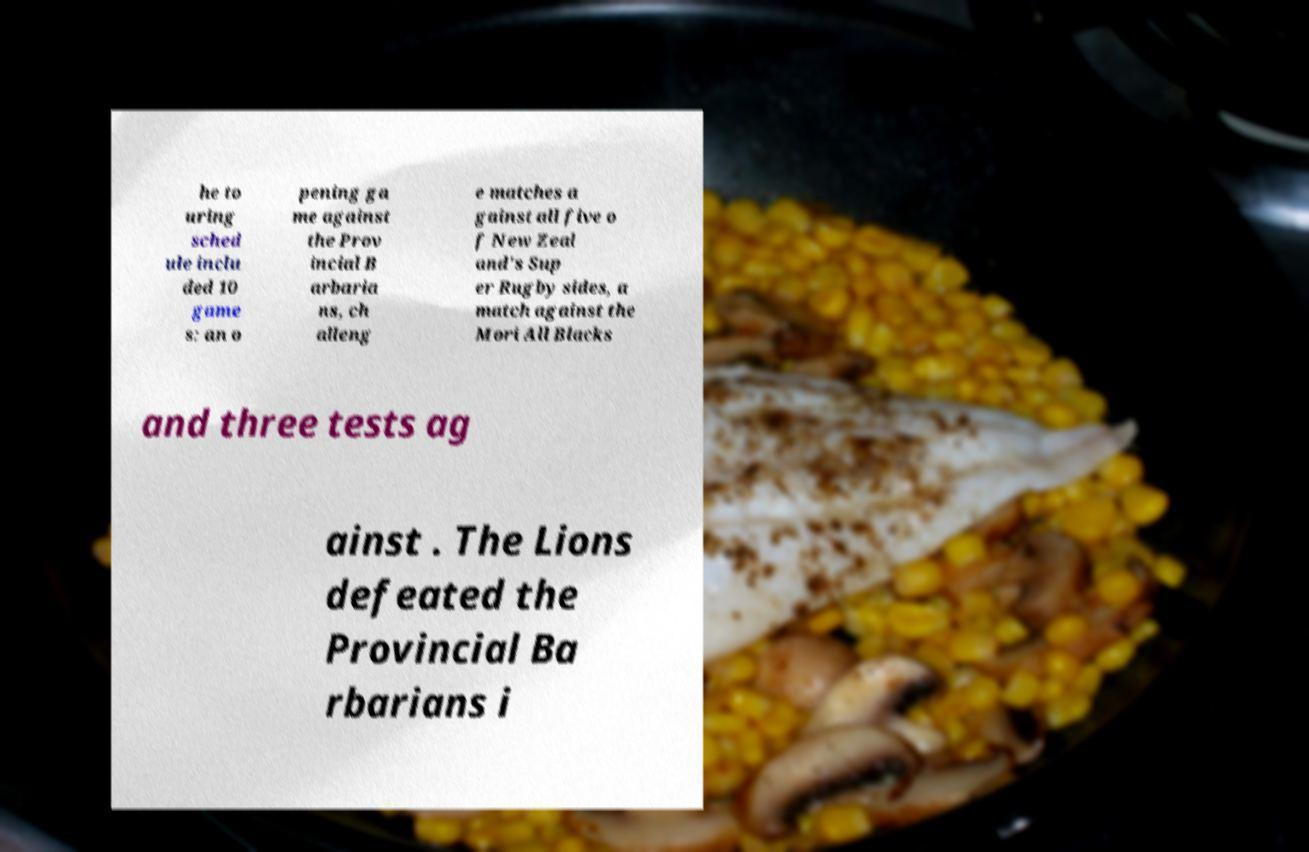Could you assist in decoding the text presented in this image and type it out clearly? he to uring sched ule inclu ded 10 game s: an o pening ga me against the Prov incial B arbaria ns, ch alleng e matches a gainst all five o f New Zeal and's Sup er Rugby sides, a match against the Mori All Blacks and three tests ag ainst . The Lions defeated the Provincial Ba rbarians i 